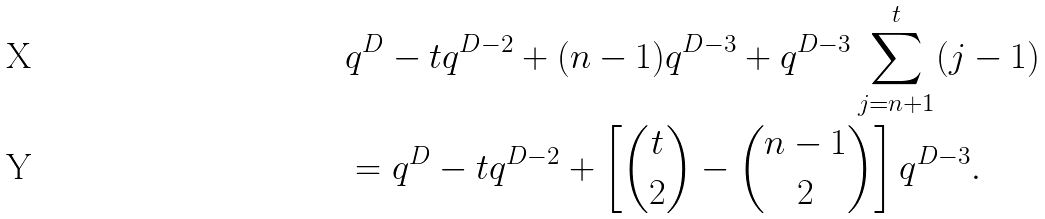<formula> <loc_0><loc_0><loc_500><loc_500>& q ^ { D } - t q ^ { D - 2 } + ( n - 1 ) q ^ { D - 3 } + q ^ { D - 3 } \sum _ { j = n + 1 } ^ { t } ( j - 1 ) \\ & = q ^ { D } - t q ^ { D - 2 } + \left [ { t \choose 2 } - { n - 1 \choose 2 } \right ] q ^ { D - 3 } .</formula> 